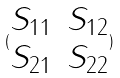Convert formula to latex. <formula><loc_0><loc_0><loc_500><loc_500>( \begin{matrix} S _ { 1 1 } & S _ { 1 2 } \\ S _ { 2 1 } & S _ { 2 2 } \end{matrix} )</formula> 